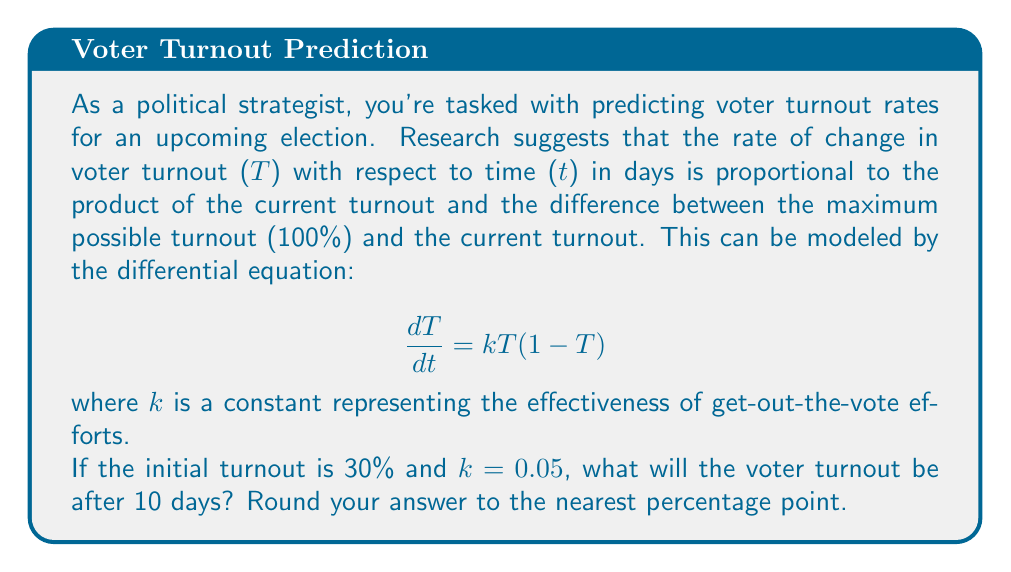Show me your answer to this math problem. To solve this problem, we need to follow these steps:

1) First, we recognize this as a logistic differential equation with the general form:
   $$\frac{dT}{dt} = kT(1-T)$$

2) The solution to this equation is given by:
   $$T(t) = \frac{1}{1 + Ce^{-kt}}$$
   where C is a constant we need to determine from the initial condition.

3) We're given that T(0) = 0.3 (30% initial turnout). Let's use this to find C:
   $$0.3 = \frac{1}{1 + C}$$
   $$1 + C = \frac{1}{0.3}$$
   $$C = \frac{1}{0.3} - 1 = \frac{10}{3} - 1 = \frac{7}{3}$$

4) Now we have our complete solution:
   $$T(t) = \frac{1}{1 + \frac{7}{3}e^{-0.05t}}$$

5) To find the turnout after 10 days, we plug in t = 10:
   $$T(10) = \frac{1}{1 + \frac{7}{3}e^{-0.5}}$$

6) Calculating this:
   $$T(10) = \frac{1}{1 + \frac{7}{3} \cdot 0.6065} = \frac{1}{1 + 1.4152} = \frac{1}{2.4152} = 0.4141$$

7) Converting to a percentage and rounding to the nearest point:
   0.4141 * 100 ≈ 41%
Answer: 41% 